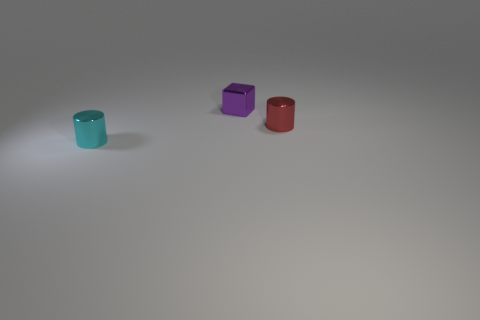Add 2 red metallic objects. How many objects exist? 5 Subtract all blocks. How many objects are left? 2 Add 2 cyan cylinders. How many cyan cylinders exist? 3 Subtract 0 green spheres. How many objects are left? 3 Subtract all tiny cubes. Subtract all cyan metal objects. How many objects are left? 1 Add 1 small red metal things. How many small red metal things are left? 2 